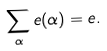Convert formula to latex. <formula><loc_0><loc_0><loc_500><loc_500>\sum _ { \alpha } e ( \alpha ) = e .</formula> 